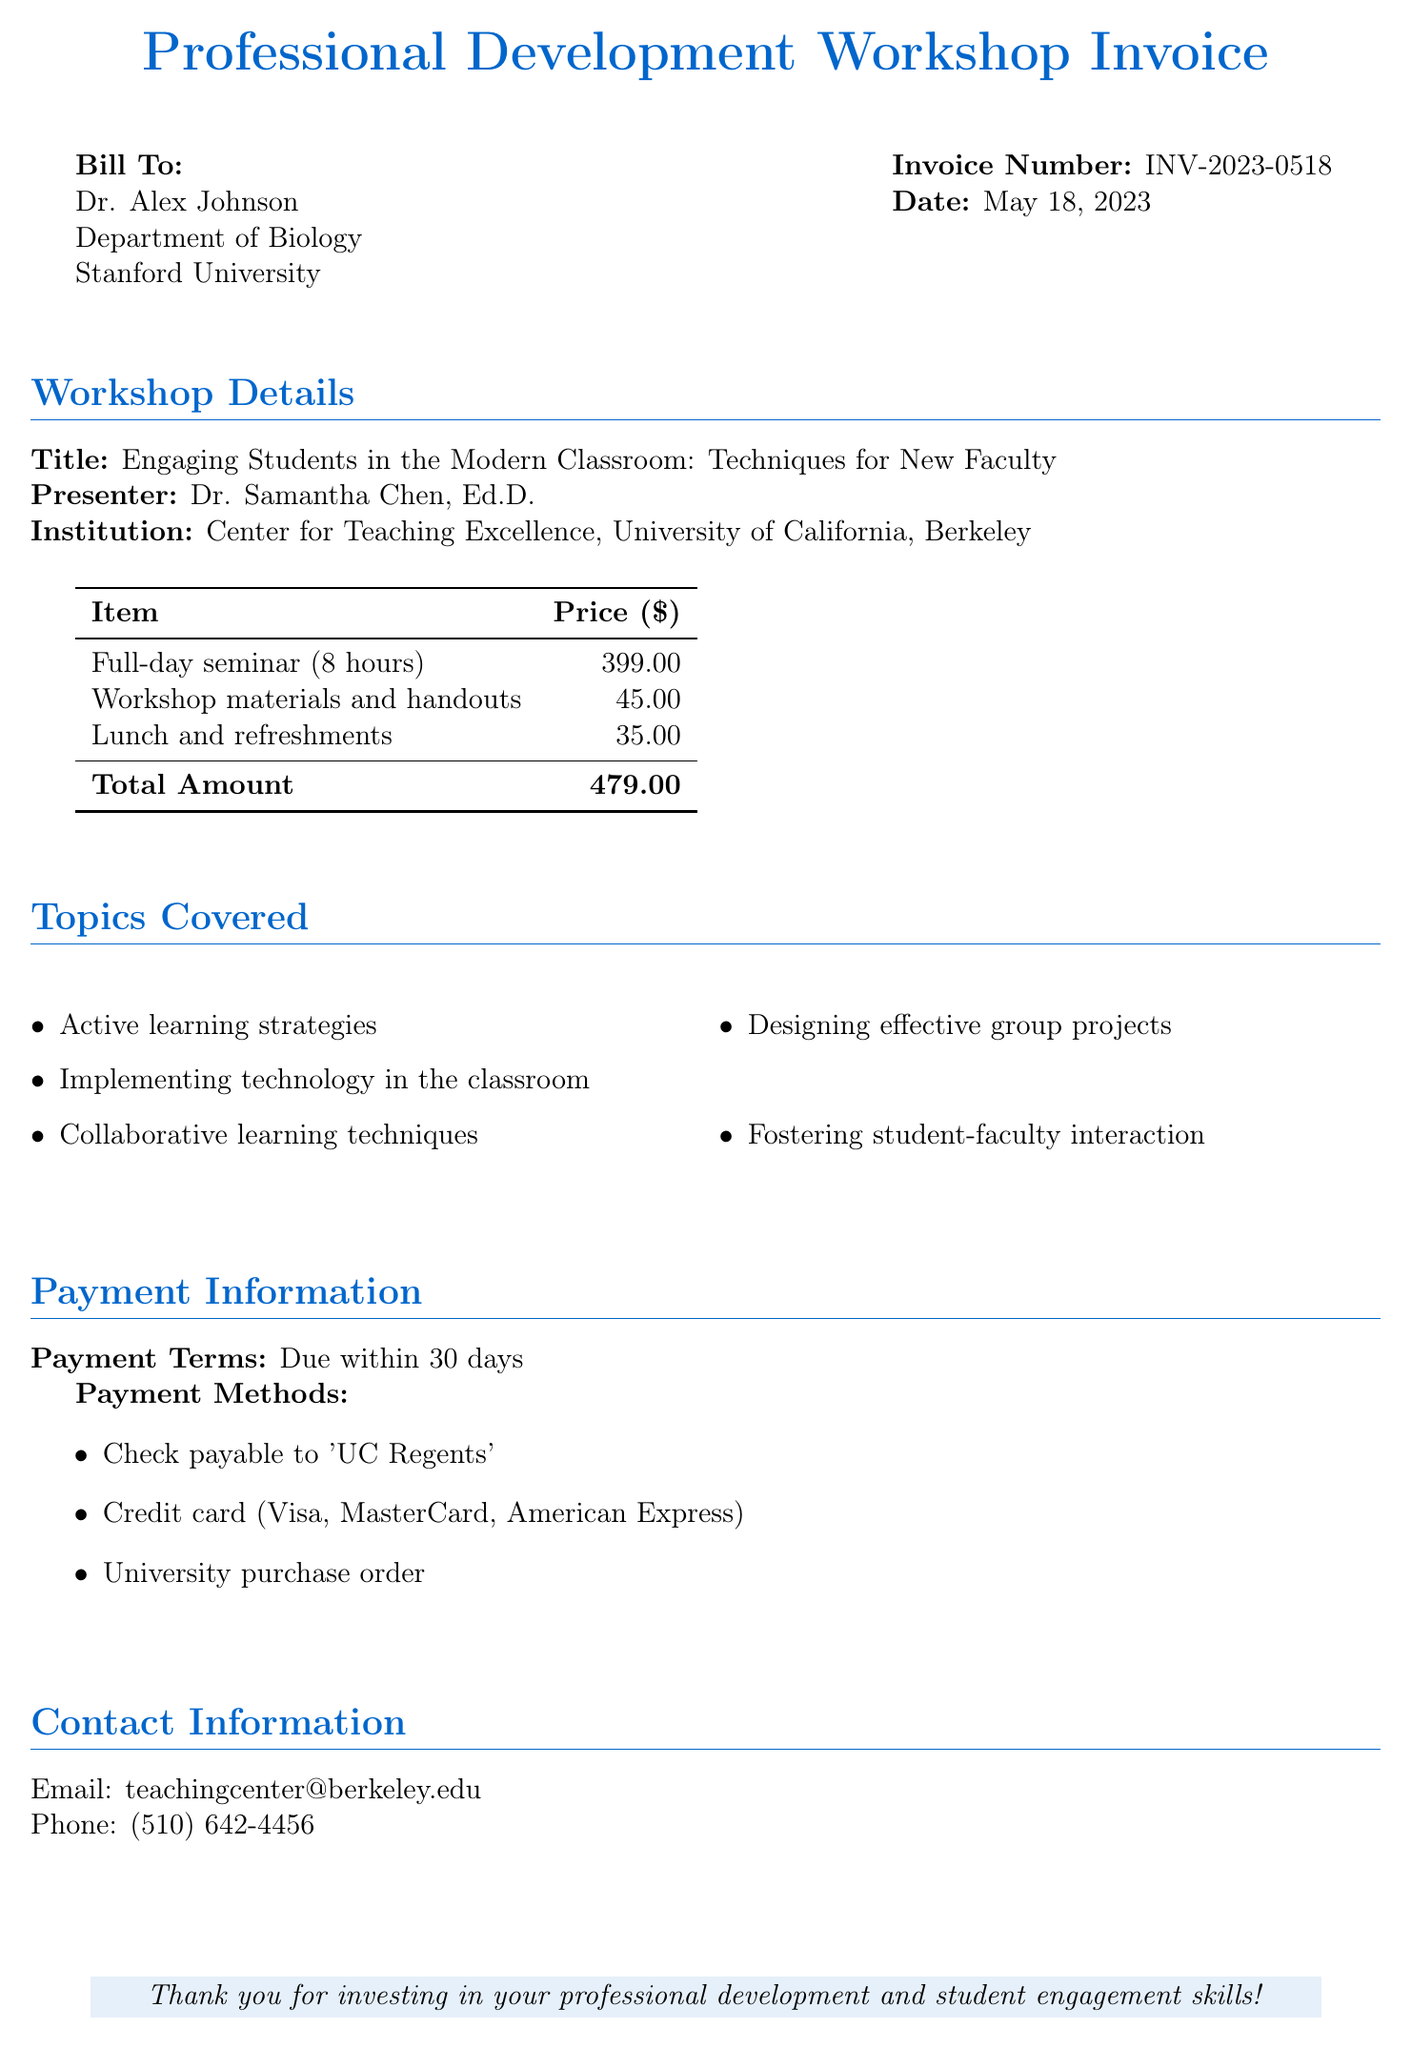What is the title of the workshop? The title of the workshop is explicitly stated in the document under Workshop Details.
Answer: Engaging Students in the Modern Classroom: Techniques for New Faculty Who is the presenter of the seminar? The presenter's name is provided in the workshop details section of the document.
Answer: Dr. Samantha Chen, Ed.D What is the total amount due on the invoice? The total amount is summarized at the bottom of the invoice table.
Answer: 479.00 What are the payment terms for the invoice? Payment terms are specified in the Payment Information section.
Answer: Due within 30 days How many hours does the seminar last? The duration of the seminar is mentioned in the items listed for the workshop.
Answer: 8 hours Which institution is associated with the presenter? The institution is mentioned in the presenter information in the document.
Answer: University of California, Berkeley What item costs $35.00? The cost of the item is detailed in the invoice table, requiring knowledge of what it pertains to.
Answer: Lunch and refreshments List one topic covered in the workshop. Topics are listed under the Topics Covered section; one could refer to the document to answer accurately.
Answer: Active learning strategies 